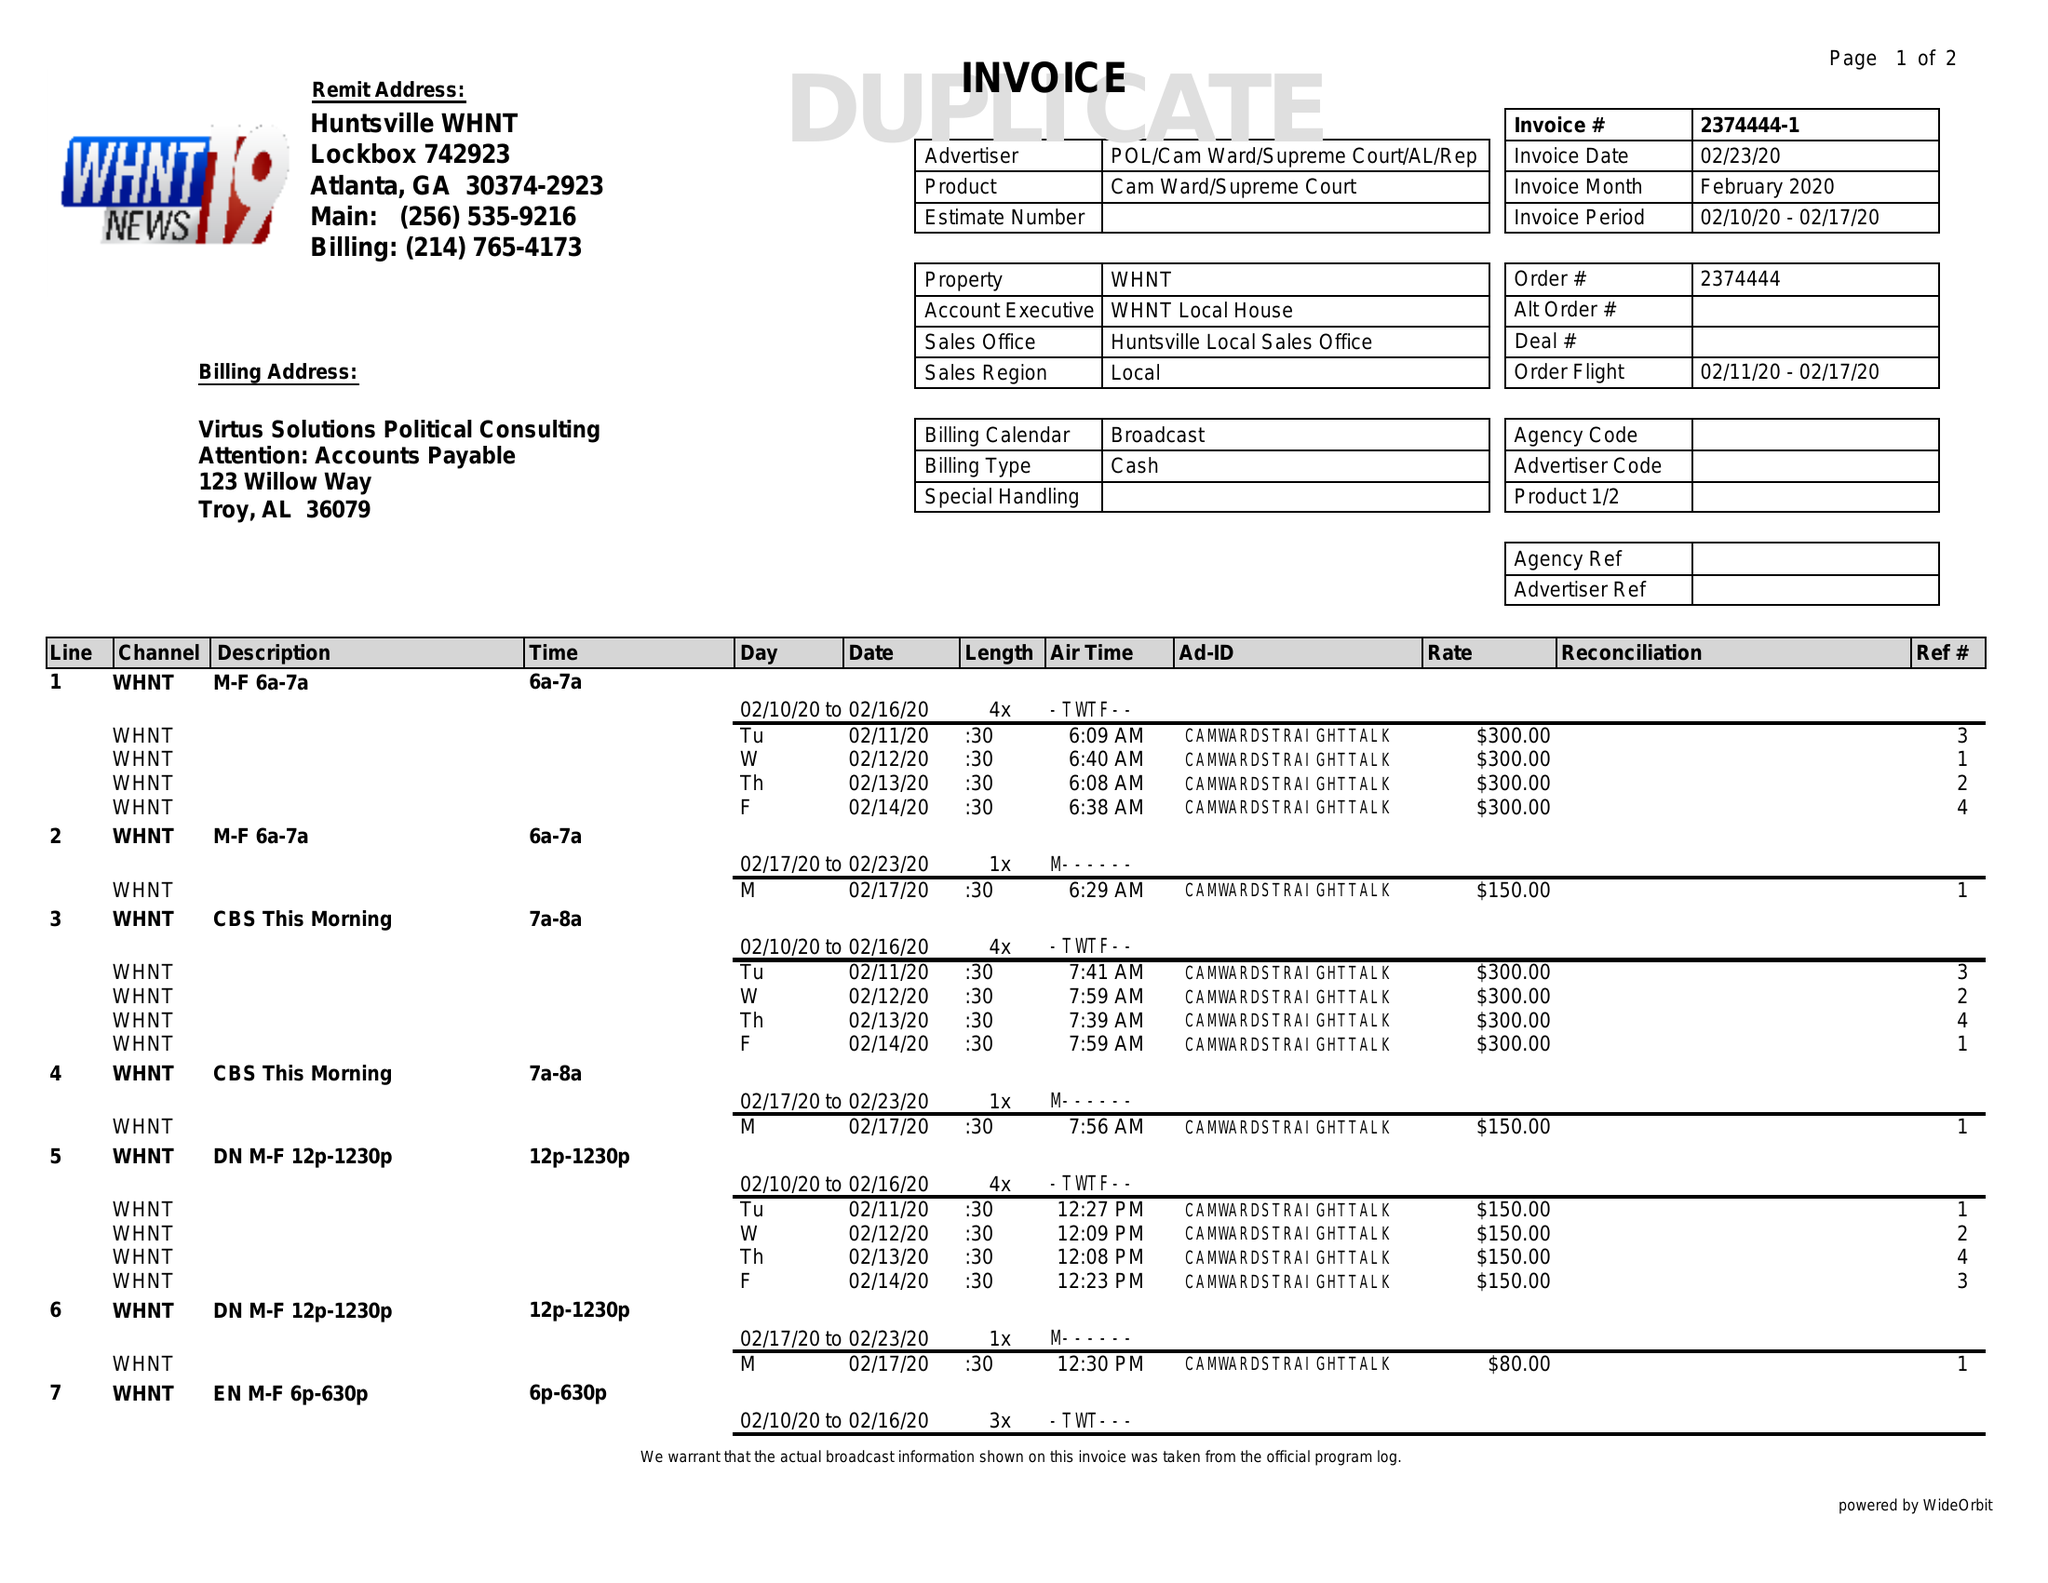What is the value for the gross_amount?
Answer the question using a single word or phrase. 5180.00 